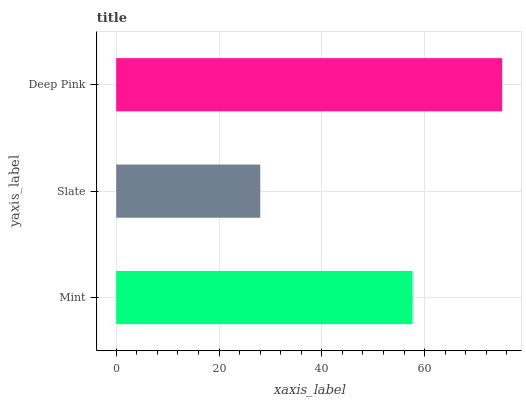Is Slate the minimum?
Answer yes or no. Yes. Is Deep Pink the maximum?
Answer yes or no. Yes. Is Deep Pink the minimum?
Answer yes or no. No. Is Slate the maximum?
Answer yes or no. No. Is Deep Pink greater than Slate?
Answer yes or no. Yes. Is Slate less than Deep Pink?
Answer yes or no. Yes. Is Slate greater than Deep Pink?
Answer yes or no. No. Is Deep Pink less than Slate?
Answer yes or no. No. Is Mint the high median?
Answer yes or no. Yes. Is Mint the low median?
Answer yes or no. Yes. Is Deep Pink the high median?
Answer yes or no. No. Is Deep Pink the low median?
Answer yes or no. No. 